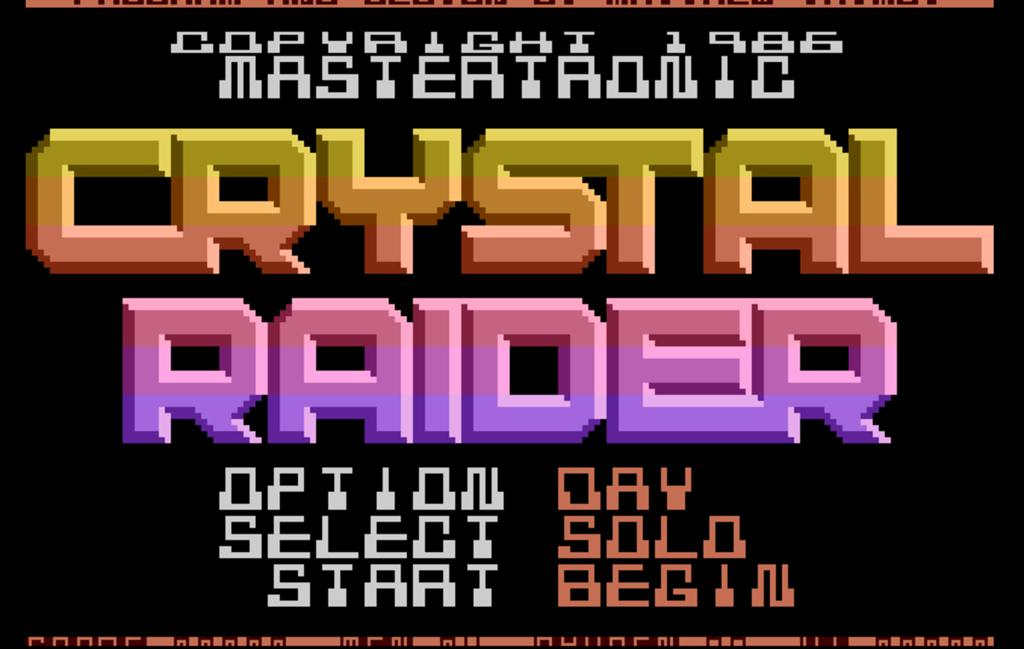<image>
Present a compact description of the photo's key features. A screen for Crystal Raider gives options to play the game 